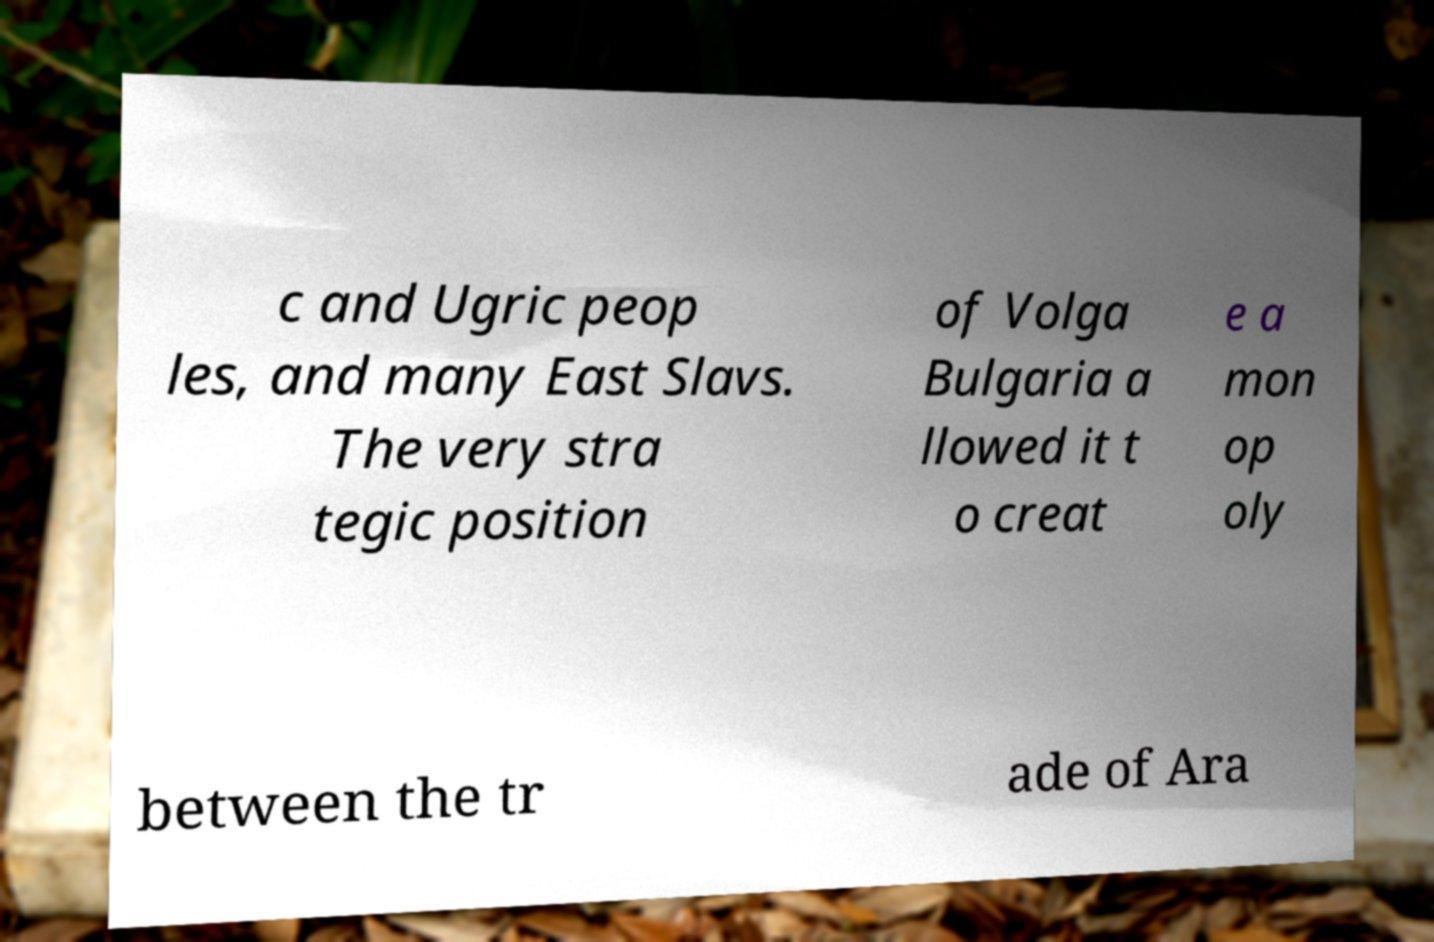Please identify and transcribe the text found in this image. c and Ugric peop les, and many East Slavs. The very stra tegic position of Volga Bulgaria a llowed it t o creat e a mon op oly between the tr ade of Ara 